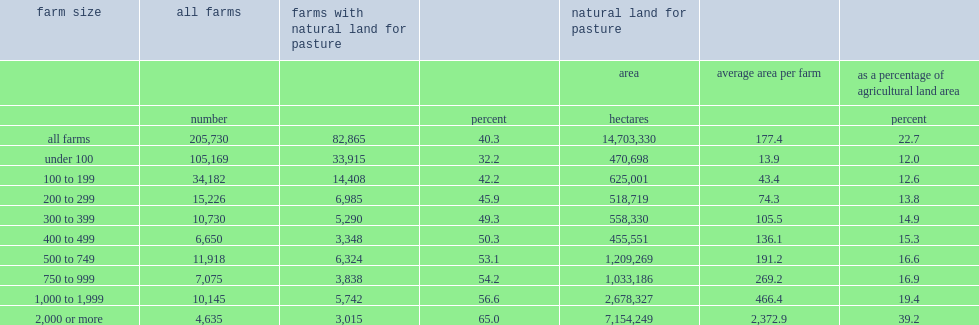Parse the full table. {'header': ['farm size', 'all farms', 'farms with natural land for pasture', '', 'natural land for pasture', '', ''], 'rows': [['', '', '', '', 'area', 'average area per farm', 'as a percentage of agricultural land area'], ['', 'number', '', 'percent', 'hectares', '', 'percent'], ['all farms', '205,730', '82,865', '40.3', '14,703,330', '177.4', '22.7'], ['under 100', '105,169', '33,915', '32.2', '470,698', '13.9', '12.0'], ['100 to 199', '34,182', '14,408', '42.2', '625,001', '43.4', '12.6'], ['200 to 299', '15,226', '6,985', '45.9', '518,719', '74.3', '13.8'], ['300 to 399', '10,730', '5,290', '49.3', '558,330', '105.5', '14.9'], ['400 to 499', '6,650', '3,348', '50.3', '455,551', '136.1', '15.3'], ['500 to 749', '11,918', '6,324', '53.1', '1,209,269', '191.2', '16.6'], ['750 to 999', '7,075', '3,838', '54.2', '1,033,186', '269.2', '16.9'], ['1,000 to 1,999', '10,145', '5,742', '56.6', '2,678,327', '466.4', '19.4'], ['2,000 or more', '4,635', '3,015', '65.0', '7,154,249', '2,372.9', '39.2']]} What was the percentage of all farms of natural land for pasture in 2011? 40.3. 